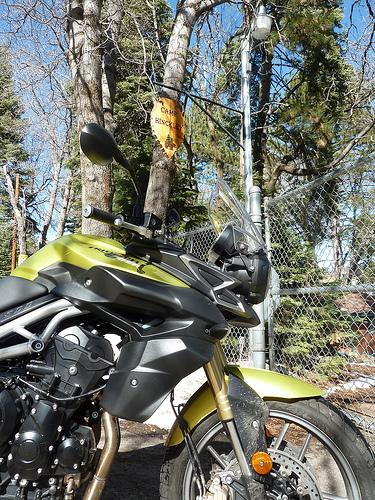Identify the main subject of the image and describe any notable features it has. The main subject is a motorcycle, featuring a black engine, black side mirror, and a black and light green color scheme. Write a short sentence about the main object in the image and its setting. The image shows a motorcycle parked near a fence, with trees and a lamp post in the background. Mention the primary object in the image and a single detail about it. A black and green motorcycle is parked in the image, with a yellow sign hanging nearby. Describe any one specific component of the main subject in the image, along with its color. The motorcycle's engine is black and located near the center of the vehicle. Write a simple sentence describing the main subject and its surroundings in the image. A motorcycle is parked by a fence, with trees and a lamp post in the background. Name the primary subject in the image and two components connected to it. A motorcycle is the primary subject, which has a handle bar and a front tire. What is the significant item in the image and one main feature it possesses? The main item is a motorcycle, and it has a black and light green color scheme. Tell me about the color and details of the main subject in the image. The motorcycle is black and light green, with a black engine and a black side mirror. Write a brief statement summarizing the main subject of the image and its immediate surroundings. A motorcycle is parked next to a gray wired fence, with a yellow sign hanging and trees in the background. List down the notable objects that can be found in the image. Motorcycle, fence, trees, lamp post, handle bar, front tire, windshield, yellow sign, and sky. 